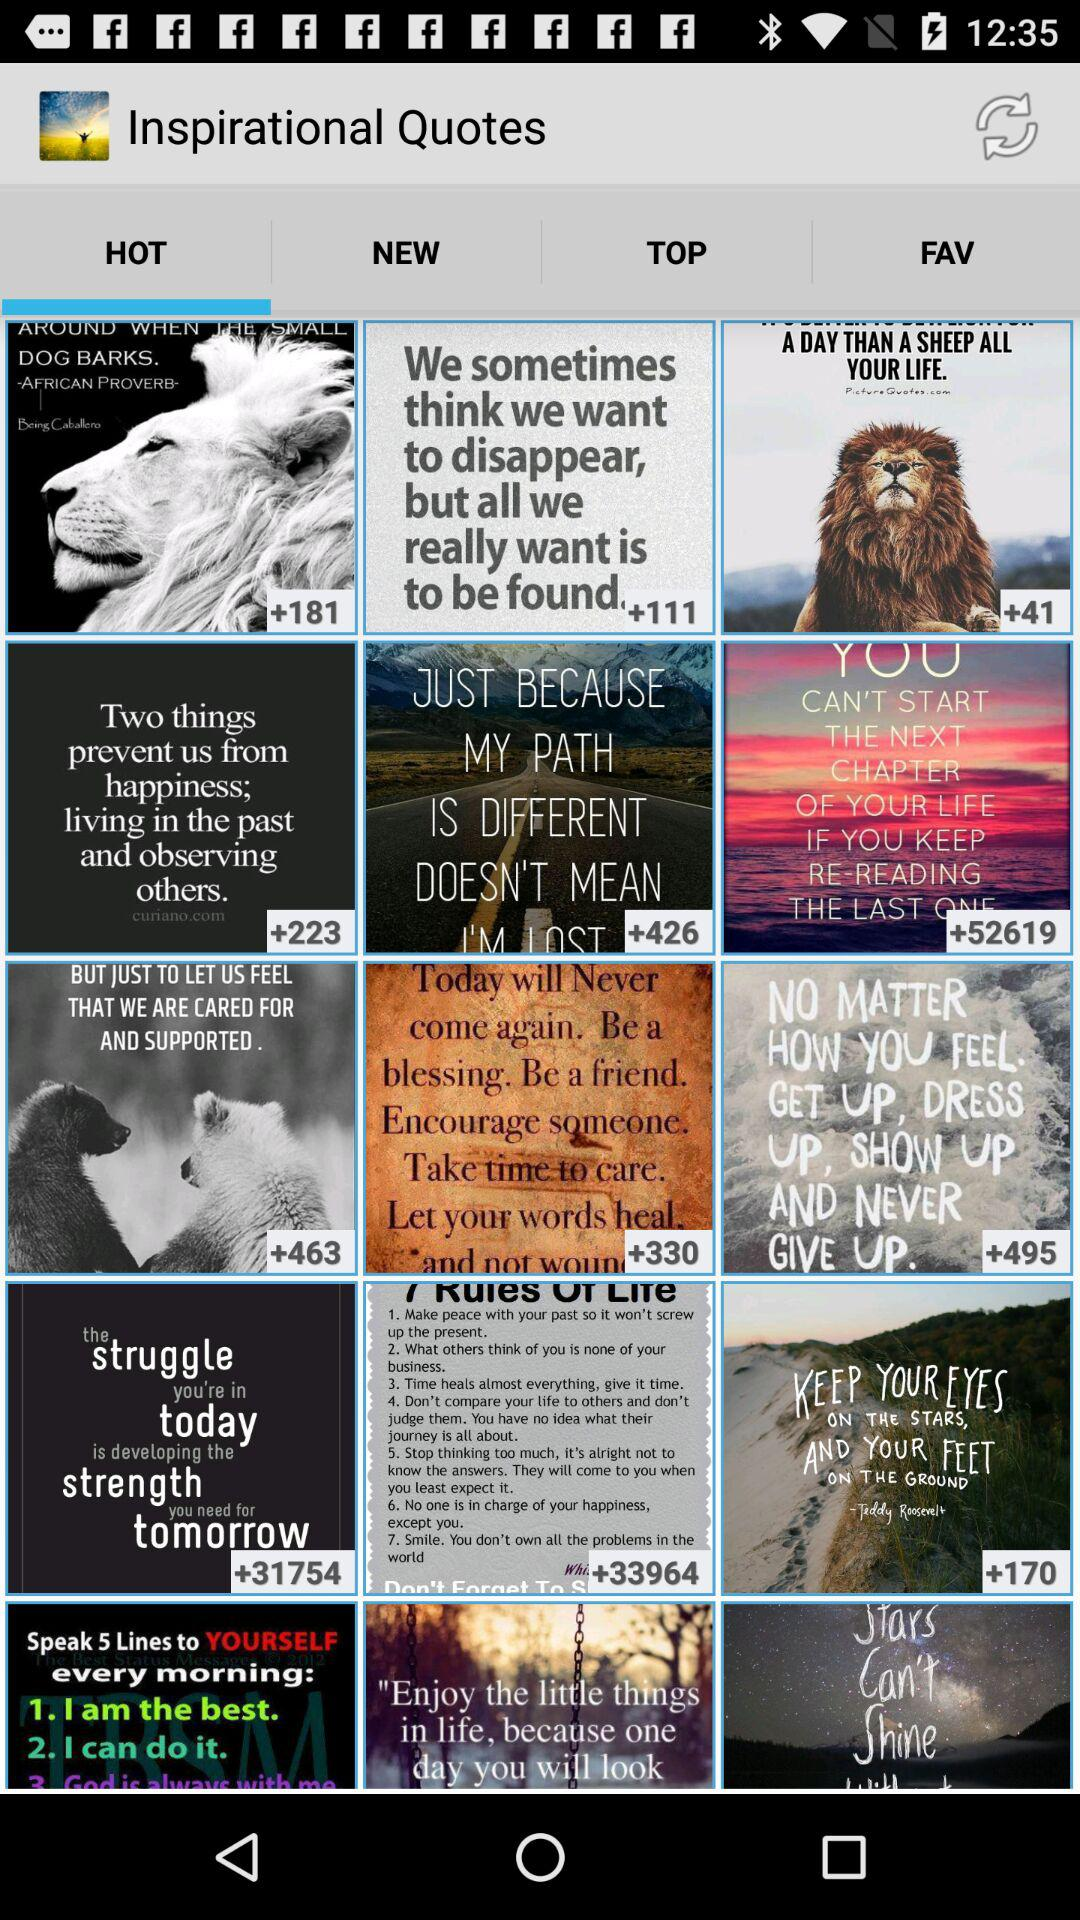What is the name of the application? The name of the application is "Inspirational Quotes". 